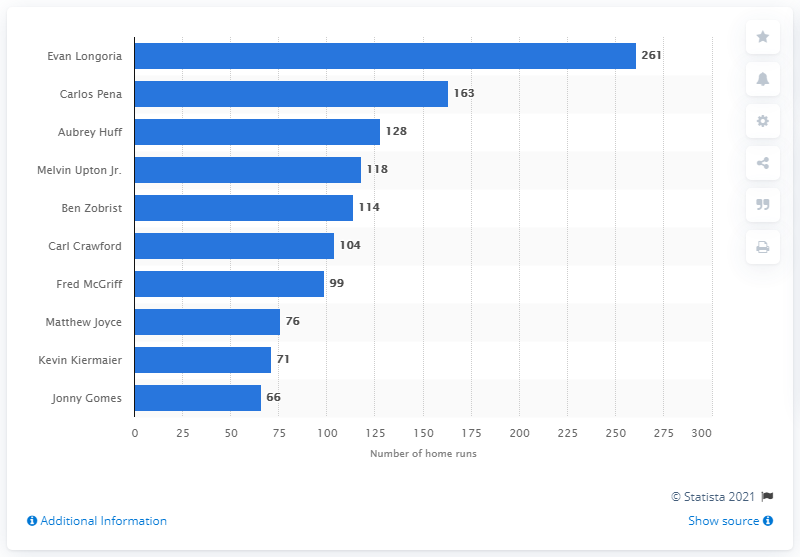Highlight a few significant elements in this photo. As of my knowledge cutoff in September 2021, Evan Longoria has hit a total of 261 home runs in his professional career. Evan Longoria holds the record for the most home runs hit in the history of the Tampa Bay Rays franchise. 